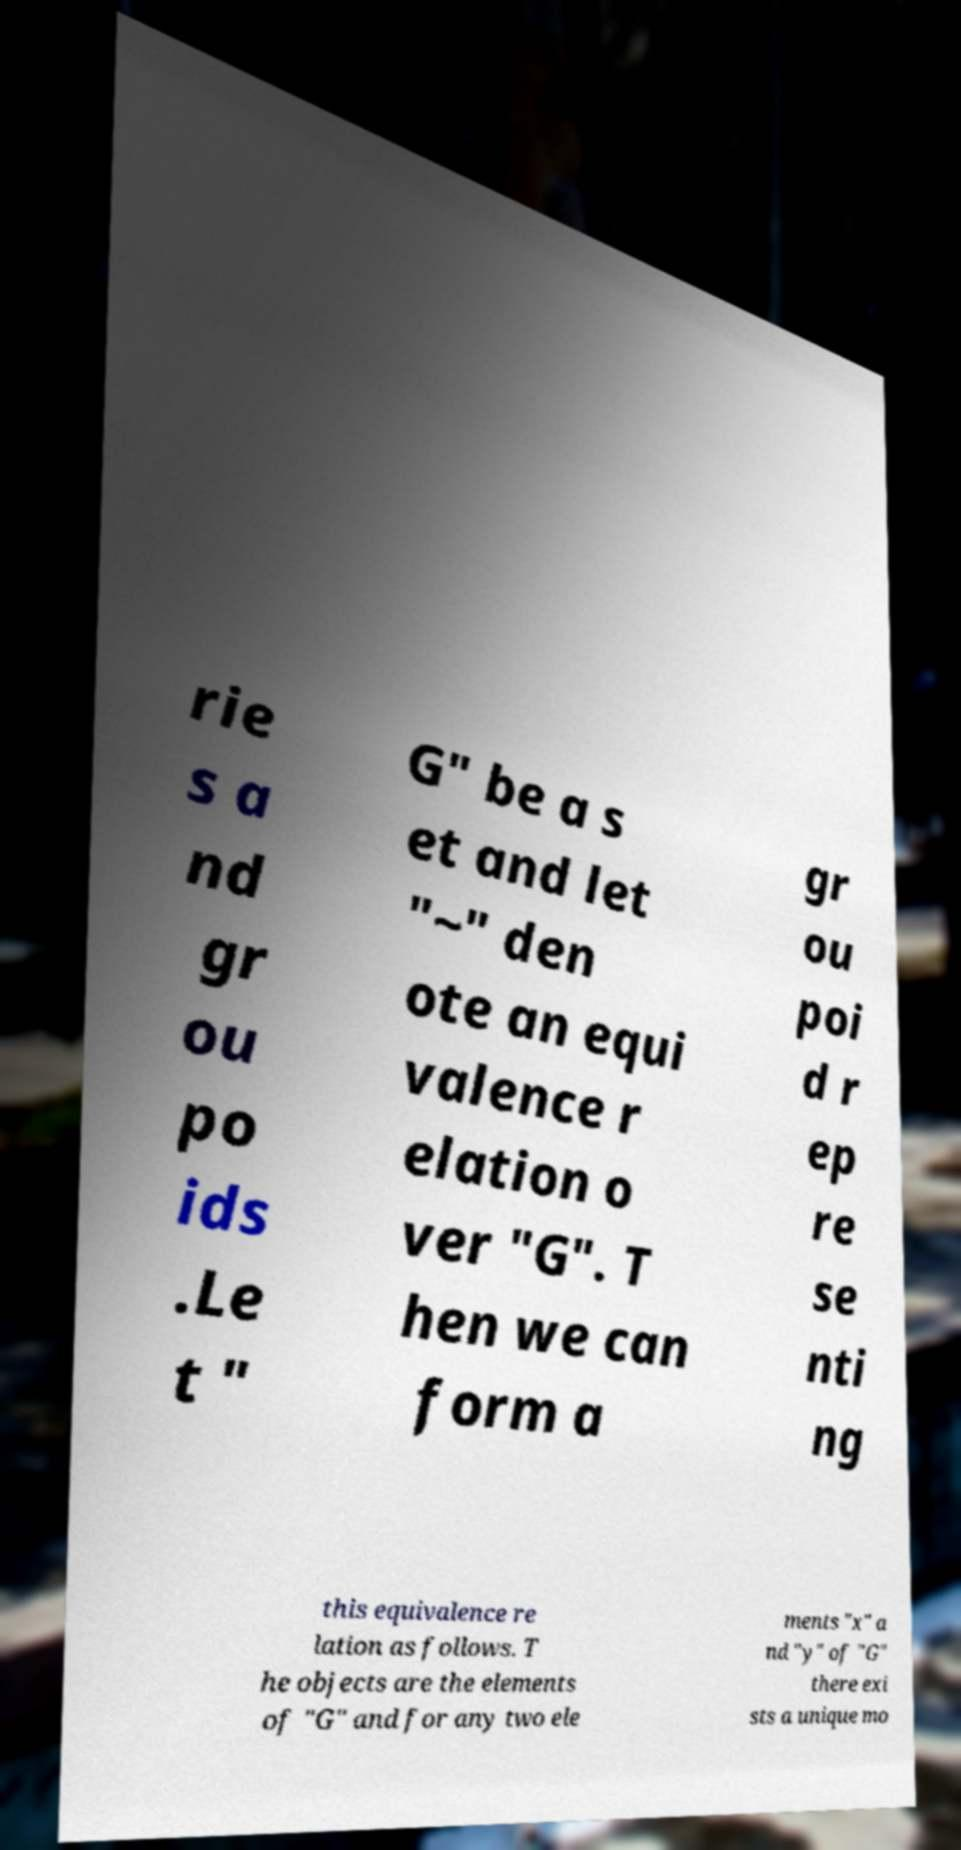There's text embedded in this image that I need extracted. Can you transcribe it verbatim? rie s a nd gr ou po ids .Le t " G" be a s et and let "~" den ote an equi valence r elation o ver "G". T hen we can form a gr ou poi d r ep re se nti ng this equivalence re lation as follows. T he objects are the elements of "G" and for any two ele ments "x" a nd "y" of "G" there exi sts a unique mo 